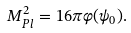Convert formula to latex. <formula><loc_0><loc_0><loc_500><loc_500>M _ { P l } ^ { 2 } = 1 6 \pi \varphi ( \psi _ { 0 } ) .</formula> 